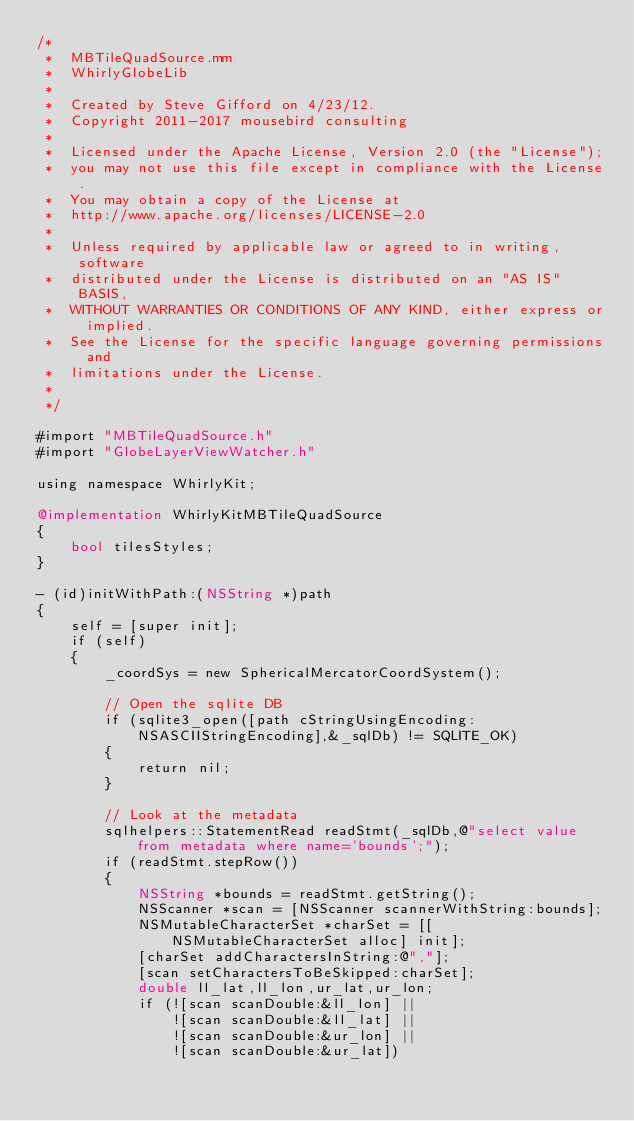Convert code to text. <code><loc_0><loc_0><loc_500><loc_500><_ObjectiveC_>/*
 *  MBTileQuadSource.mm
 *  WhirlyGlobeLib
 *
 *  Created by Steve Gifford on 4/23/12.
 *  Copyright 2011-2017 mousebird consulting
 *
 *  Licensed under the Apache License, Version 2.0 (the "License");
 *  you may not use this file except in compliance with the License.
 *  You may obtain a copy of the License at
 *  http://www.apache.org/licenses/LICENSE-2.0
 *
 *  Unless required by applicable law or agreed to in writing, software
 *  distributed under the License is distributed on an "AS IS" BASIS,
 *  WITHOUT WARRANTIES OR CONDITIONS OF ANY KIND, either express or implied.
 *  See the License for the specific language governing permissions and
 *  limitations under the License.
 *
 */

#import "MBTileQuadSource.h"
#import "GlobeLayerViewWatcher.h"

using namespace WhirlyKit;

@implementation WhirlyKitMBTileQuadSource
{
    bool tilesStyles;
}

- (id)initWithPath:(NSString *)path
{
    self = [super init];
    if (self)
    {
        _coordSys = new SphericalMercatorCoordSystem();
        
        // Open the sqlite DB
        if (sqlite3_open([path cStringUsingEncoding:NSASCIIStringEncoding],&_sqlDb) != SQLITE_OK)
        {
            return nil;
        }
        
        // Look at the metadata
        sqlhelpers::StatementRead readStmt(_sqlDb,@"select value from metadata where name='bounds';");
        if (readStmt.stepRow())
        {
            NSString *bounds = readStmt.getString();
            NSScanner *scan = [NSScanner scannerWithString:bounds];
            NSMutableCharacterSet *charSet = [[NSMutableCharacterSet alloc] init];
            [charSet addCharactersInString:@","];
            [scan setCharactersToBeSkipped:charSet];
            double ll_lat,ll_lon,ur_lat,ur_lon;
            if (![scan scanDouble:&ll_lon] ||
                ![scan scanDouble:&ll_lat] ||
                ![scan scanDouble:&ur_lon] ||
                ![scan scanDouble:&ur_lat])</code> 